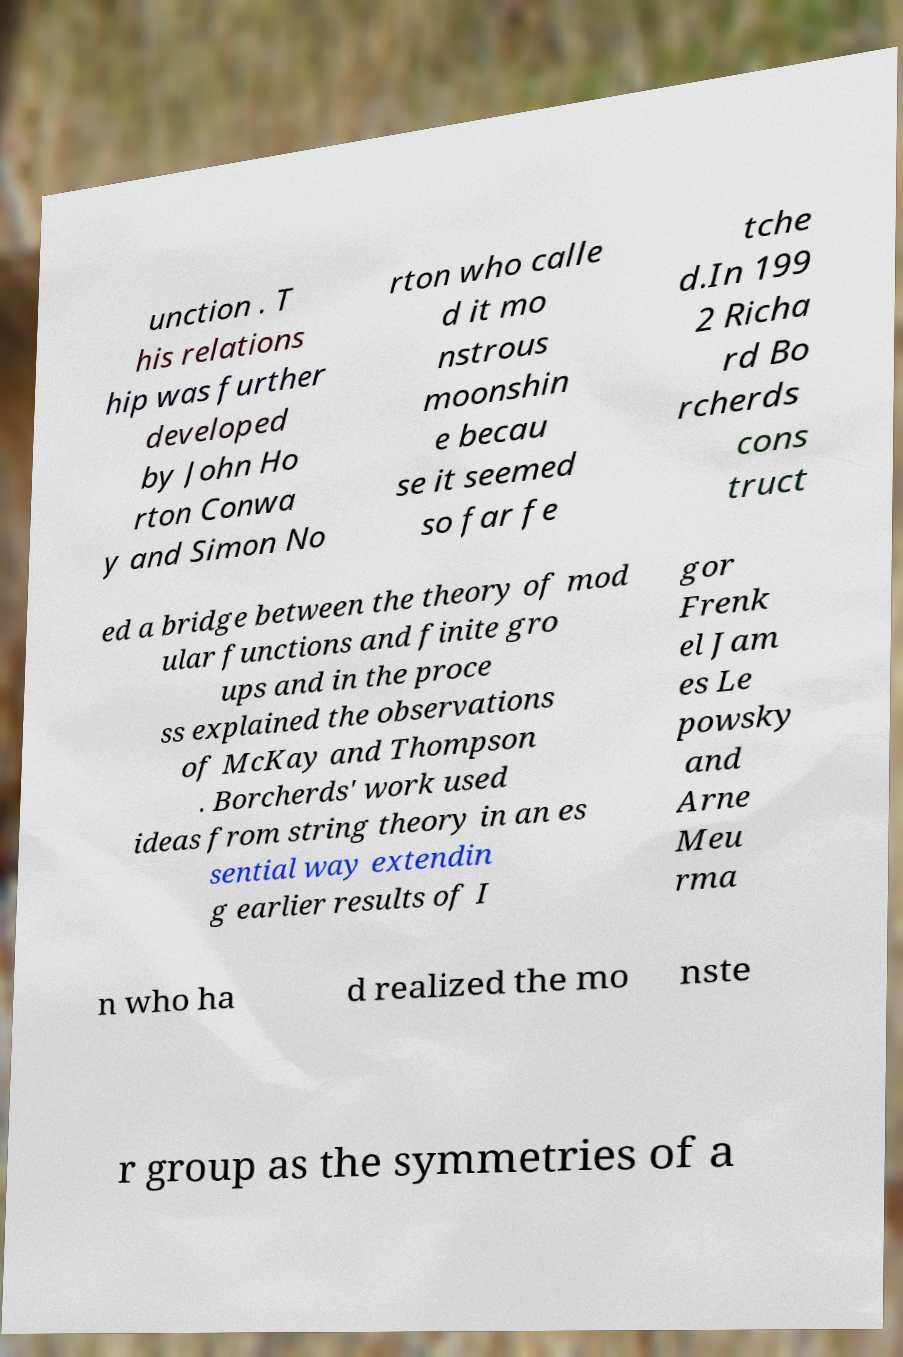Can you accurately transcribe the text from the provided image for me? unction . T his relations hip was further developed by John Ho rton Conwa y and Simon No rton who calle d it mo nstrous moonshin e becau se it seemed so far fe tche d.In 199 2 Richa rd Bo rcherds cons truct ed a bridge between the theory of mod ular functions and finite gro ups and in the proce ss explained the observations of McKay and Thompson . Borcherds' work used ideas from string theory in an es sential way extendin g earlier results of I gor Frenk el Jam es Le powsky and Arne Meu rma n who ha d realized the mo nste r group as the symmetries of a 